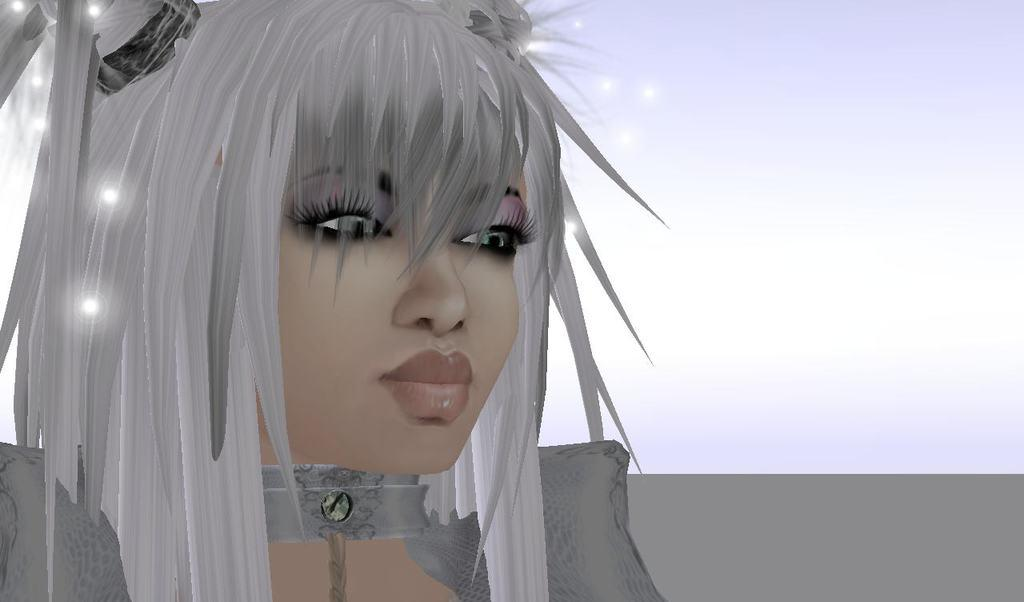What style is used in the image? The image appears to be an anime-style depiction. Who is the main subject in the image? There is a girl in the image. What is the color of the girl's hair? The girl has white hair. What is the girl wearing in the image? The girl is wearing a grey dress. What color is the background of the image? The background of the image is white. What type of business is the girl running in the image? There is no indication of a business in the image; it features a girl with white hair and a grey dress in an anime-style depiction. 